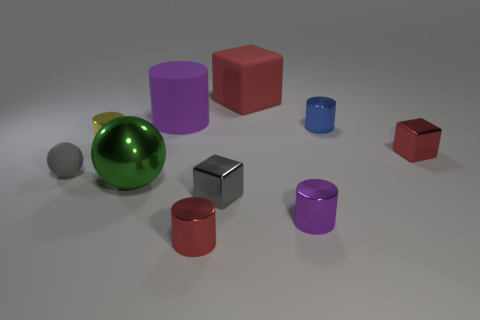Subtract all small gray cubes. How many cubes are left? 2 Subtract all gray balls. How many purple cylinders are left? 2 Subtract all red cylinders. How many cylinders are left? 4 Subtract 1 cylinders. How many cylinders are left? 4 Subtract all blue cylinders. Subtract all blue spheres. How many cylinders are left? 4 Subtract all spheres. How many objects are left? 8 Subtract all small blue metallic cylinders. Subtract all large red cubes. How many objects are left? 8 Add 7 rubber spheres. How many rubber spheres are left? 8 Add 9 purple blocks. How many purple blocks exist? 9 Subtract 1 gray spheres. How many objects are left? 9 